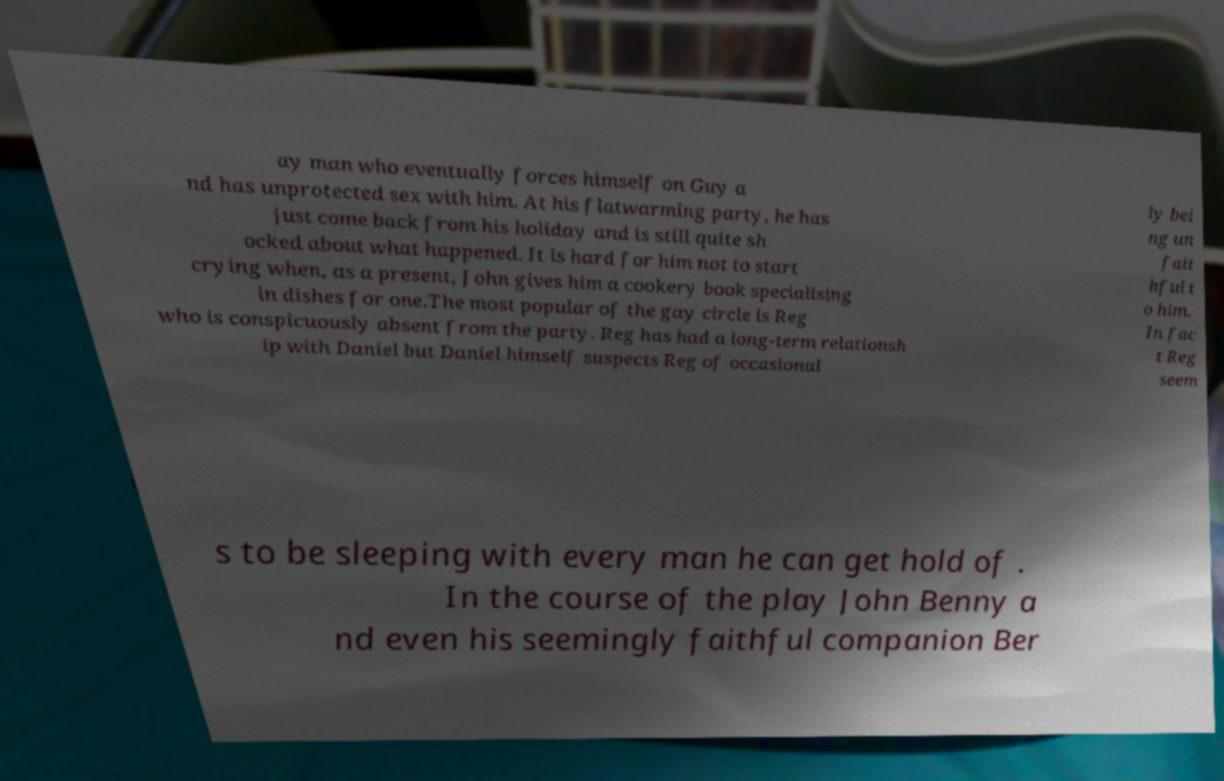For documentation purposes, I need the text within this image transcribed. Could you provide that? ay man who eventually forces himself on Guy a nd has unprotected sex with him. At his flatwarming party, he has just come back from his holiday and is still quite sh ocked about what happened. It is hard for him not to start crying when, as a present, John gives him a cookery book specialising in dishes for one.The most popular of the gay circle is Reg who is conspicuously absent from the party. Reg has had a long-term relationsh ip with Daniel but Daniel himself suspects Reg of occasional ly bei ng un fait hful t o him. In fac t Reg seem s to be sleeping with every man he can get hold of . In the course of the play John Benny a nd even his seemingly faithful companion Ber 